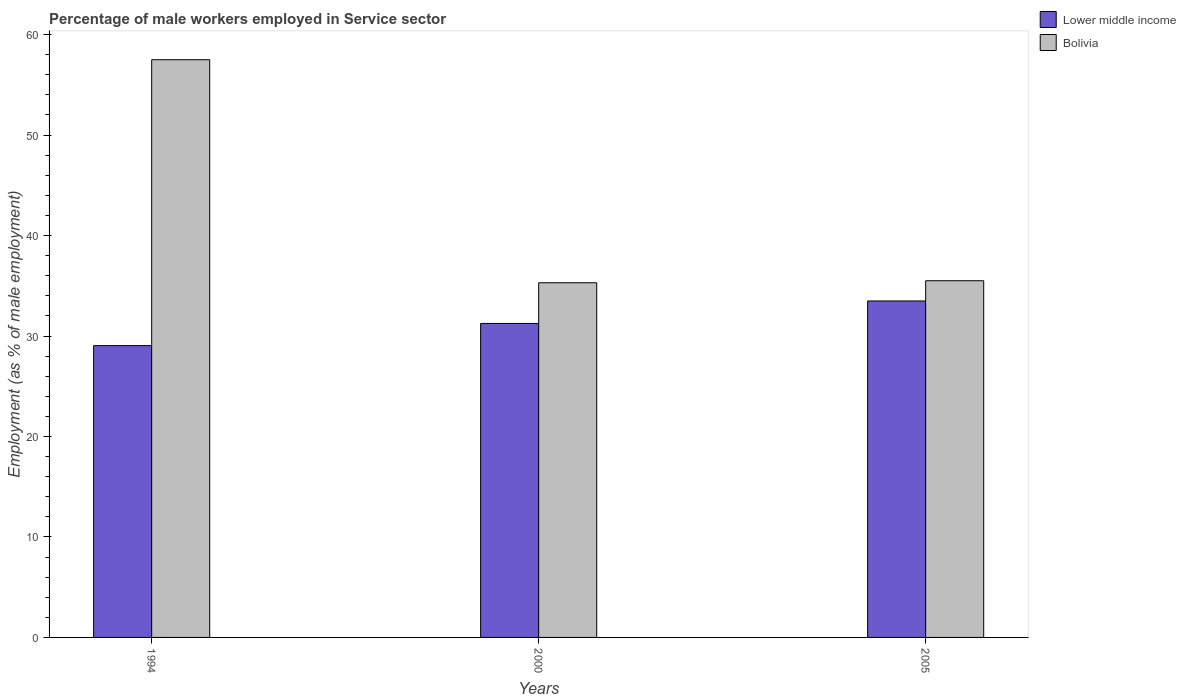How many different coloured bars are there?
Offer a very short reply. 2. How many groups of bars are there?
Offer a very short reply. 3. Are the number of bars per tick equal to the number of legend labels?
Make the answer very short. Yes. In how many cases, is the number of bars for a given year not equal to the number of legend labels?
Your response must be concise. 0. What is the percentage of male workers employed in Service sector in Lower middle income in 1994?
Make the answer very short. 29.04. Across all years, what is the maximum percentage of male workers employed in Service sector in Bolivia?
Ensure brevity in your answer.  57.5. Across all years, what is the minimum percentage of male workers employed in Service sector in Bolivia?
Provide a short and direct response. 35.3. In which year was the percentage of male workers employed in Service sector in Lower middle income maximum?
Your answer should be compact. 2005. What is the total percentage of male workers employed in Service sector in Lower middle income in the graph?
Ensure brevity in your answer.  93.78. What is the difference between the percentage of male workers employed in Service sector in Lower middle income in 1994 and that in 2005?
Give a very brief answer. -4.44. What is the difference between the percentage of male workers employed in Service sector in Lower middle income in 2005 and the percentage of male workers employed in Service sector in Bolivia in 1994?
Make the answer very short. -24.01. What is the average percentage of male workers employed in Service sector in Lower middle income per year?
Give a very brief answer. 31.26. In the year 2000, what is the difference between the percentage of male workers employed in Service sector in Bolivia and percentage of male workers employed in Service sector in Lower middle income?
Your response must be concise. 4.05. In how many years, is the percentage of male workers employed in Service sector in Lower middle income greater than 28 %?
Provide a succinct answer. 3. What is the ratio of the percentage of male workers employed in Service sector in Lower middle income in 2000 to that in 2005?
Your response must be concise. 0.93. Is the percentage of male workers employed in Service sector in Lower middle income in 1994 less than that in 2000?
Your response must be concise. Yes. Is the difference between the percentage of male workers employed in Service sector in Bolivia in 1994 and 2005 greater than the difference between the percentage of male workers employed in Service sector in Lower middle income in 1994 and 2005?
Keep it short and to the point. Yes. What is the difference between the highest and the second highest percentage of male workers employed in Service sector in Lower middle income?
Provide a succinct answer. 2.24. What is the difference between the highest and the lowest percentage of male workers employed in Service sector in Lower middle income?
Your answer should be compact. 4.44. What does the 1st bar from the left in 2005 represents?
Your response must be concise. Lower middle income. How many bars are there?
Ensure brevity in your answer.  6. How many years are there in the graph?
Ensure brevity in your answer.  3. What is the difference between two consecutive major ticks on the Y-axis?
Provide a succinct answer. 10. Are the values on the major ticks of Y-axis written in scientific E-notation?
Ensure brevity in your answer.  No. Does the graph contain any zero values?
Keep it short and to the point. No. Does the graph contain grids?
Your response must be concise. No. Where does the legend appear in the graph?
Ensure brevity in your answer.  Top right. What is the title of the graph?
Give a very brief answer. Percentage of male workers employed in Service sector. What is the label or title of the X-axis?
Ensure brevity in your answer.  Years. What is the label or title of the Y-axis?
Provide a short and direct response. Employment (as % of male employment). What is the Employment (as % of male employment) in Lower middle income in 1994?
Make the answer very short. 29.04. What is the Employment (as % of male employment) in Bolivia in 1994?
Make the answer very short. 57.5. What is the Employment (as % of male employment) in Lower middle income in 2000?
Offer a terse response. 31.25. What is the Employment (as % of male employment) of Bolivia in 2000?
Keep it short and to the point. 35.3. What is the Employment (as % of male employment) of Lower middle income in 2005?
Your answer should be very brief. 33.49. What is the Employment (as % of male employment) in Bolivia in 2005?
Your answer should be very brief. 35.5. Across all years, what is the maximum Employment (as % of male employment) of Lower middle income?
Give a very brief answer. 33.49. Across all years, what is the maximum Employment (as % of male employment) in Bolivia?
Ensure brevity in your answer.  57.5. Across all years, what is the minimum Employment (as % of male employment) of Lower middle income?
Keep it short and to the point. 29.04. Across all years, what is the minimum Employment (as % of male employment) in Bolivia?
Make the answer very short. 35.3. What is the total Employment (as % of male employment) of Lower middle income in the graph?
Offer a very short reply. 93.78. What is the total Employment (as % of male employment) in Bolivia in the graph?
Make the answer very short. 128.3. What is the difference between the Employment (as % of male employment) of Lower middle income in 1994 and that in 2000?
Offer a very short reply. -2.21. What is the difference between the Employment (as % of male employment) in Bolivia in 1994 and that in 2000?
Provide a short and direct response. 22.2. What is the difference between the Employment (as % of male employment) of Lower middle income in 1994 and that in 2005?
Give a very brief answer. -4.44. What is the difference between the Employment (as % of male employment) in Lower middle income in 2000 and that in 2005?
Your answer should be very brief. -2.24. What is the difference between the Employment (as % of male employment) in Bolivia in 2000 and that in 2005?
Provide a succinct answer. -0.2. What is the difference between the Employment (as % of male employment) in Lower middle income in 1994 and the Employment (as % of male employment) in Bolivia in 2000?
Your response must be concise. -6.26. What is the difference between the Employment (as % of male employment) in Lower middle income in 1994 and the Employment (as % of male employment) in Bolivia in 2005?
Your response must be concise. -6.46. What is the difference between the Employment (as % of male employment) of Lower middle income in 2000 and the Employment (as % of male employment) of Bolivia in 2005?
Provide a succinct answer. -4.25. What is the average Employment (as % of male employment) in Lower middle income per year?
Offer a very short reply. 31.26. What is the average Employment (as % of male employment) in Bolivia per year?
Your response must be concise. 42.77. In the year 1994, what is the difference between the Employment (as % of male employment) in Lower middle income and Employment (as % of male employment) in Bolivia?
Make the answer very short. -28.46. In the year 2000, what is the difference between the Employment (as % of male employment) of Lower middle income and Employment (as % of male employment) of Bolivia?
Offer a terse response. -4.05. In the year 2005, what is the difference between the Employment (as % of male employment) in Lower middle income and Employment (as % of male employment) in Bolivia?
Your answer should be very brief. -2.01. What is the ratio of the Employment (as % of male employment) of Lower middle income in 1994 to that in 2000?
Offer a very short reply. 0.93. What is the ratio of the Employment (as % of male employment) in Bolivia in 1994 to that in 2000?
Provide a succinct answer. 1.63. What is the ratio of the Employment (as % of male employment) of Lower middle income in 1994 to that in 2005?
Offer a very short reply. 0.87. What is the ratio of the Employment (as % of male employment) of Bolivia in 1994 to that in 2005?
Give a very brief answer. 1.62. What is the ratio of the Employment (as % of male employment) of Lower middle income in 2000 to that in 2005?
Make the answer very short. 0.93. What is the ratio of the Employment (as % of male employment) of Bolivia in 2000 to that in 2005?
Ensure brevity in your answer.  0.99. What is the difference between the highest and the second highest Employment (as % of male employment) in Lower middle income?
Your answer should be very brief. 2.24. What is the difference between the highest and the lowest Employment (as % of male employment) of Lower middle income?
Give a very brief answer. 4.44. 